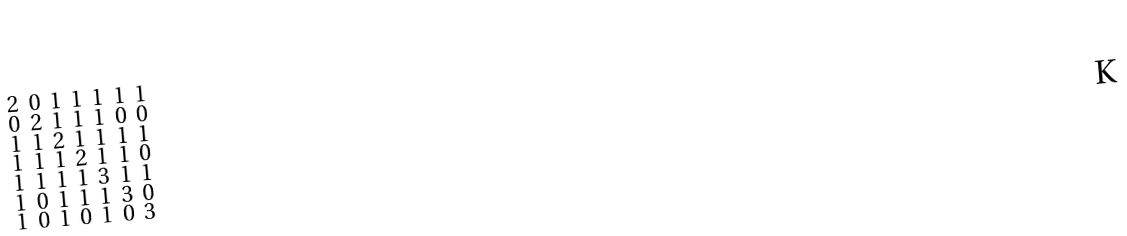<formula> <loc_0><loc_0><loc_500><loc_500>\begin{smallmatrix} 2 & 0 & 1 & 1 & 1 & 1 & 1 \\ 0 & 2 & 1 & 1 & 1 & 0 & 0 \\ 1 & 1 & 2 & 1 & 1 & 1 & 1 \\ 1 & 1 & 1 & 2 & 1 & 1 & 0 \\ 1 & 1 & 1 & 1 & 3 & 1 & 1 \\ 1 & 0 & 1 & 1 & 1 & 3 & 0 \\ 1 & 0 & 1 & 0 & 1 & 0 & 3 \end{smallmatrix}</formula> 